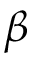<formula> <loc_0><loc_0><loc_500><loc_500>\beta</formula> 